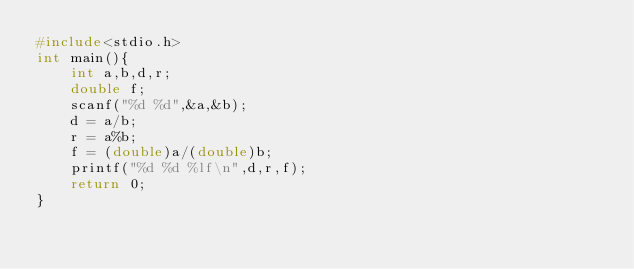Convert code to text. <code><loc_0><loc_0><loc_500><loc_500><_C_>#include<stdio.h>
int main(){
    int a,b,d,r;
    double f;
    scanf("%d %d",&a,&b);
    d = a/b;
    r = a%b;
    f = (double)a/(double)b;
    printf("%d %d %lf\n",d,r,f);
    return 0;
}</code> 